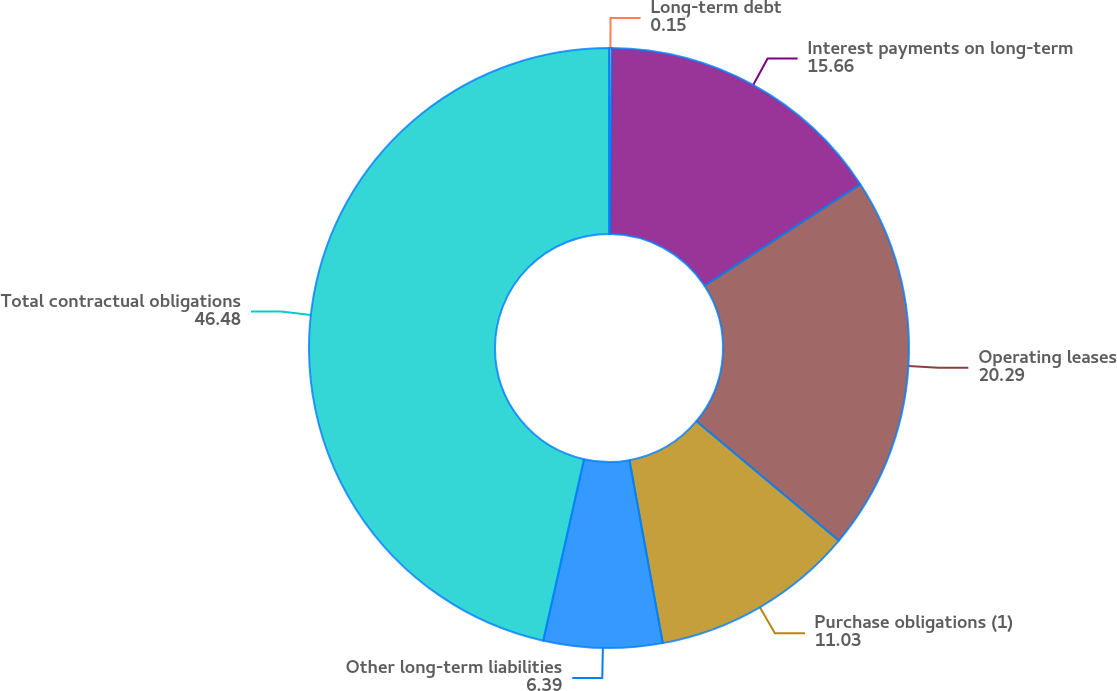Convert chart. <chart><loc_0><loc_0><loc_500><loc_500><pie_chart><fcel>Long-term debt<fcel>Interest payments on long-term<fcel>Operating leases<fcel>Purchase obligations (1)<fcel>Other long-term liabilities<fcel>Total contractual obligations<nl><fcel>0.15%<fcel>15.66%<fcel>20.29%<fcel>11.03%<fcel>6.39%<fcel>46.48%<nl></chart> 